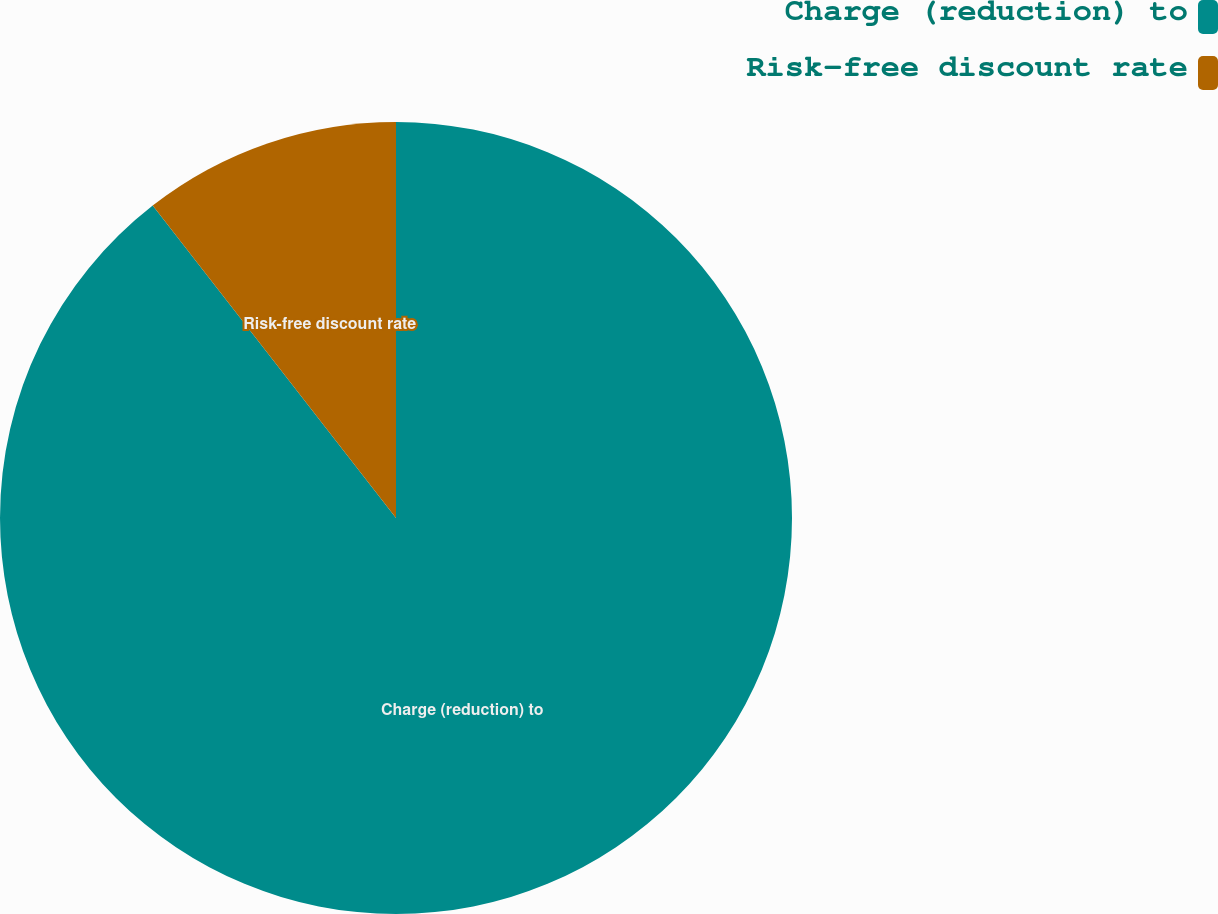Convert chart. <chart><loc_0><loc_0><loc_500><loc_500><pie_chart><fcel>Charge (reduction) to<fcel>Risk-free discount rate<nl><fcel>89.47%<fcel>10.53%<nl></chart> 